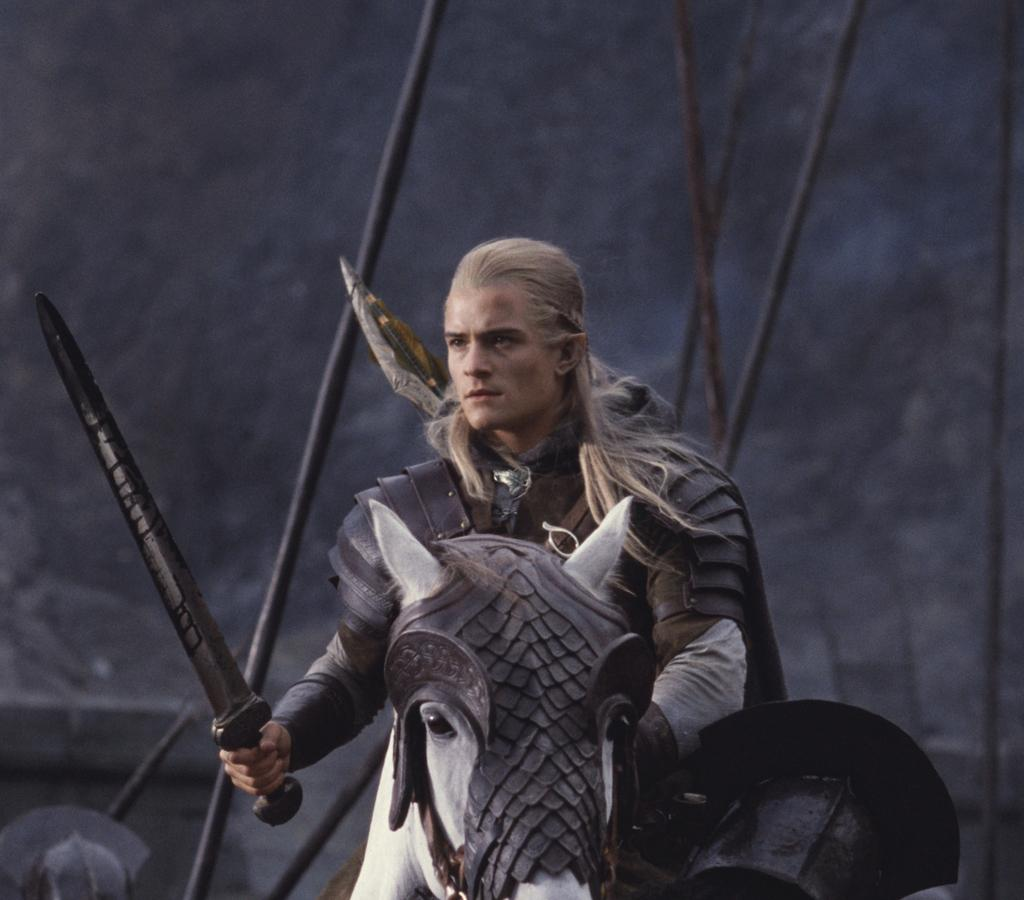What is the main subject of the image? There is a person in the image. What is the person wearing? The person is wearing clothes. What is the person holding in their hand? The person is holding a sword in their hand. What is the person sitting on? The person is sitting on a horse. What can be seen in the background of the image? The background of the image is grayish dark. Can you see any sail or seashore in the image? No, there is no sail or seashore present in the image. What type of attraction is the person visiting in the image? There is no indication of an attraction in the image; it primarily features a person sitting on a horse with a sword. 